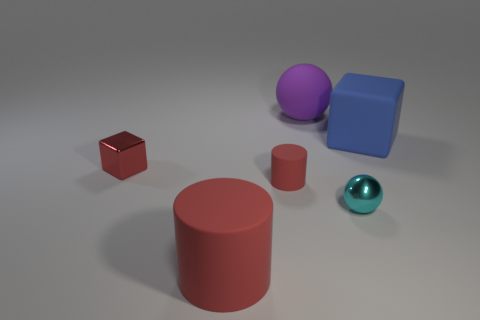Add 4 cyan shiny things. How many objects exist? 10 Subtract all cylinders. How many objects are left? 4 Subtract all blue cubes. Subtract all red cylinders. How many cubes are left? 1 Subtract all tiny things. Subtract all tiny cylinders. How many objects are left? 2 Add 6 metal objects. How many metal objects are left? 8 Add 5 big cylinders. How many big cylinders exist? 6 Subtract 1 red blocks. How many objects are left? 5 